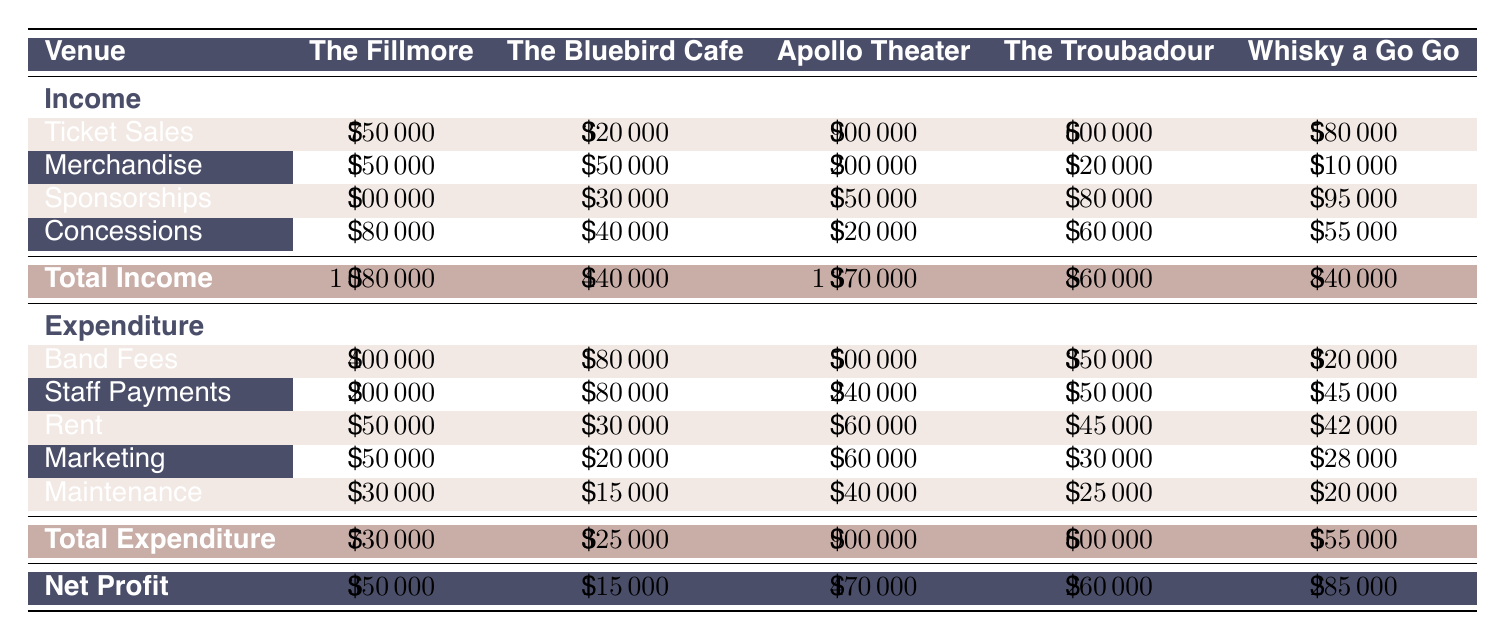What is the total income for The Fillmore? The total income for The Fillmore can be found in the table under the "Total Income" row. It is listed as 1,080,000.
Answer: 1,080,000 What was the total expenditure for the Apollo Theater? The total expenditure for the Apollo Theater can be found in the table under the "Total Expenditure" row. It shows 900,000.
Answer: 900,000 Is the net profit for The Bluebird Cafe greater than 100,000? The net profit for The Bluebird Cafe is listed in the table as 115,000, which is indeed greater than 100,000.
Answer: Yes What is the difference between the total income of The Troubadour and Whisky a Go Go? The total income for The Troubadour is 860,000 and for Whisky a Go Go is 840,000. To find the difference, subtract 840,000 from 860,000, resulting in a difference of 20,000.
Answer: 20,000 Which venue had the highest expenditure? To find the venue with the highest expenditure, we compare the total expenditure values: The Fillmore (730,000), The Bluebird Cafe (325,000), Apollo Theater (900,000), The Troubadour (600,000), and Whisky a Go Go (555,000). The Apollo Theater has the highest expenditure at 900,000.
Answer: Apollo Theater What is the average net profit of all the venues? To calculate the average net profit, first sum all the net profits: 350,000 (The Fillmore) + 115,000 (The Bluebird Cafe) + 470,000 (Apollo Theater) + 260,000 (The Troubadour) + 285,000 (Whisky a Go Go) = 1,480,000. There are 5 venues, so the average net profit is 1,480,000 divided by 5, which equals 296,000.
Answer: 296,000 Did the total income exceed the total expenditure for The Troubadour? The total income for The Troubadour is 860,000, while the total expenditure is 600,000. Since 860,000 is greater than 600,000, the total income does exceed the total expenditure.
Answer: Yes What percentage of the total income for The Fillmore comes from ticket sales? The total income for The Fillmore is 1,080,000, and ticket sales contribute 750,000. To find the percentage, divide 750,000 by 1,080,000 and multiply by 100: (750,000 / 1,080,000) * 100 = 69.44%.
Answer: 69.44% Which venue had the lowest staff payments? In the table, the staff payments for each venue are as follows: The Fillmore (200,000), The Bluebird Cafe (80,000), Apollo Theater (240,000), The Troubadour (150,000), and Whisky a Go Go (145,000). The Bluebird Cafe has the lowest staff payments at 80,000.
Answer: The Bluebird Cafe 